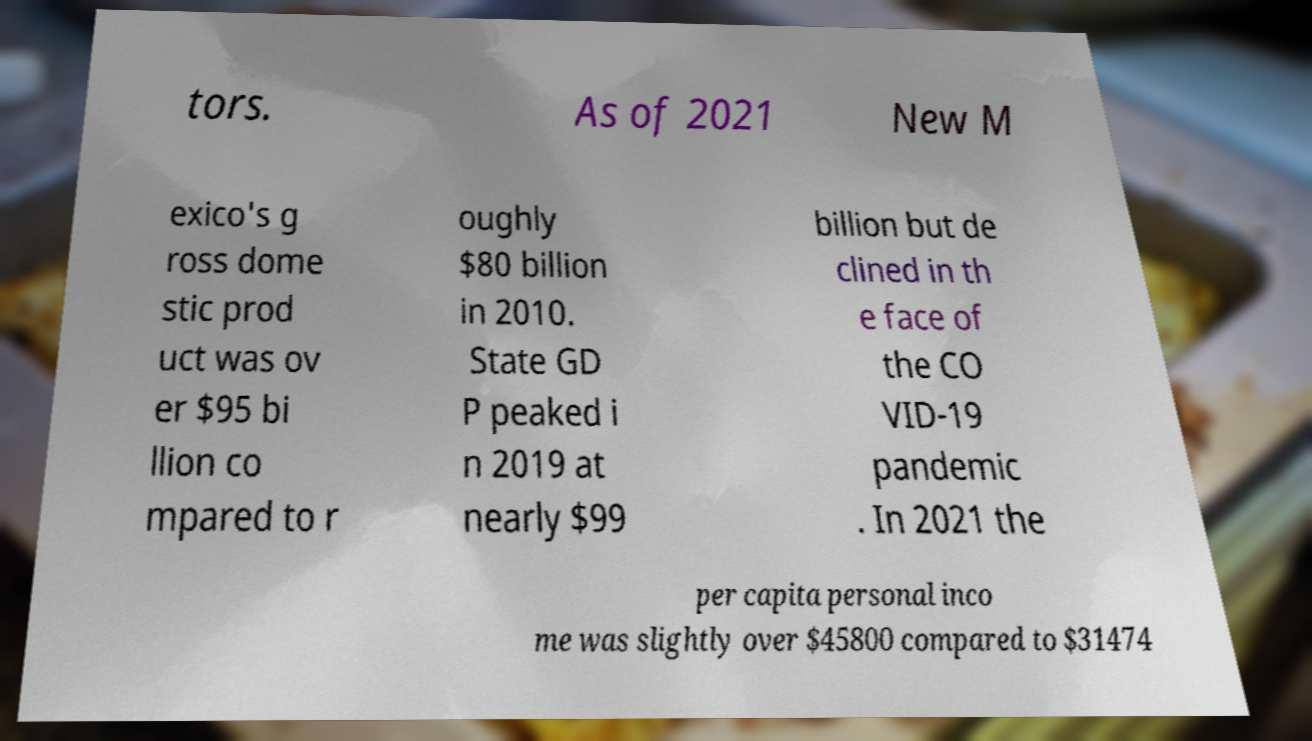I need the written content from this picture converted into text. Can you do that? tors. As of 2021 New M exico's g ross dome stic prod uct was ov er $95 bi llion co mpared to r oughly $80 billion in 2010. State GD P peaked i n 2019 at nearly $99 billion but de clined in th e face of the CO VID-19 pandemic . In 2021 the per capita personal inco me was slightly over $45800 compared to $31474 